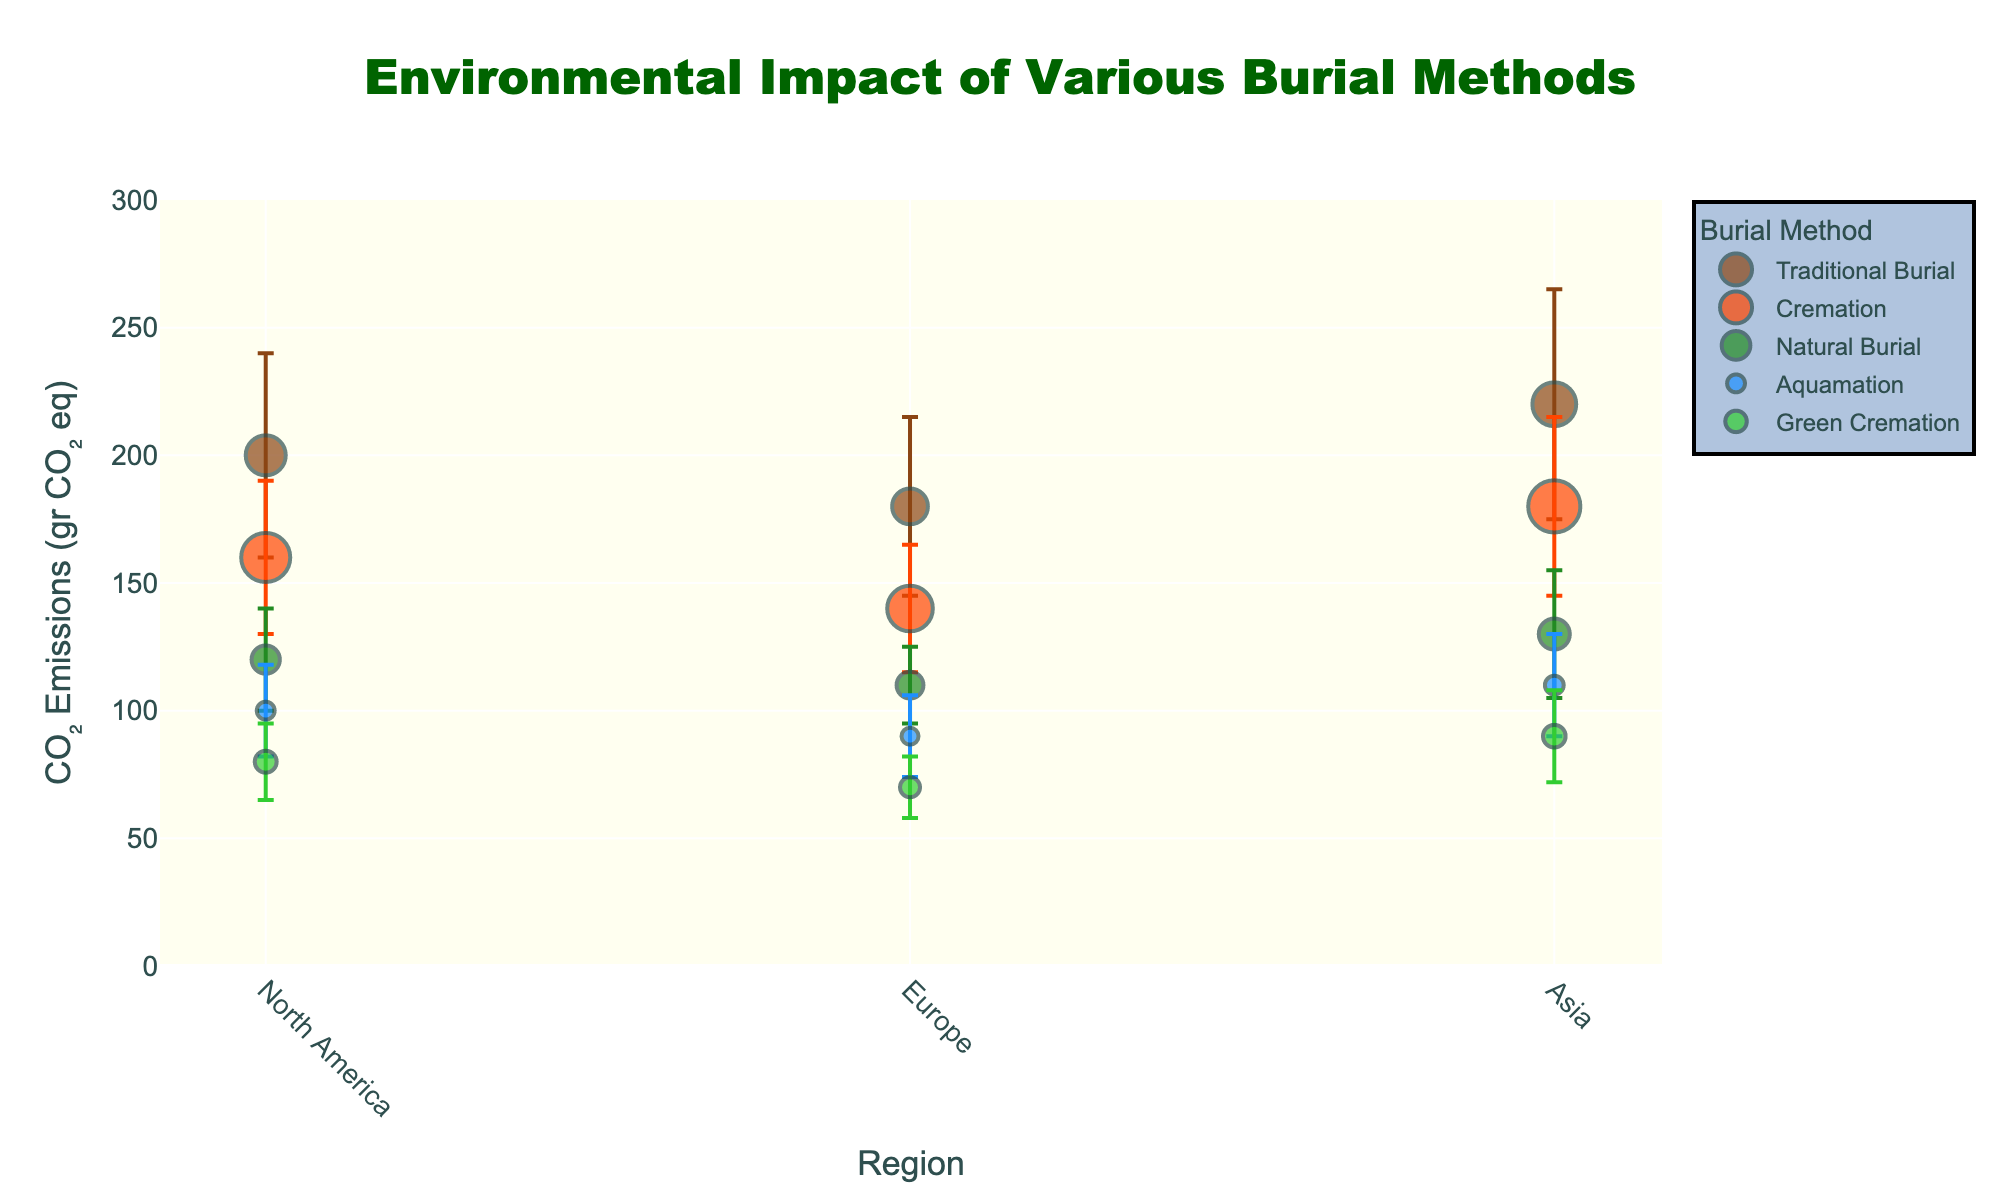What is the title of the figure? The title is usually found at the top of the figure, often in larger or bold text. In this case, it reads "Environmental Impact of Various Burial Methods".
Answer: Environmental Impact of Various Burial Methods Which burial method has the smallest CO₂ emissions in Europe? Looking at the region 'Europe' on the x-axis and comparing the y-axis values, Green Cremation has the smallest CO₂ emissions.
Answer: Green Cremation How do the CO₂ emissions for Traditional Burial in Asia compare to those in Europe? In Asia, Traditional Burial has CO₂ emissions around 220 gr CO₂ eq, while in Europe it is around 180 gr CO₂ eq. Thus, Asia has higher emissions.
Answer: Higher in Asia Which region has the most significant spread in CO₂ emissions for Natural Burial? The spread can be determined by looking at the error bars. For Natural Burial, Asia has the largest error bar (25 gr CO₂ eq), indicating the most significant spread.
Answer: Asia What is the range of CO₂ emissions for Cremation in North America, considering the error bars? The mean value for Cremation in North America is 160 gr CO₂ eq with an error of 30 gr CO₂ eq. So the range is from 130 to 190 gr CO₂ eq.
Answer: 130 to 190 gr CO₂ eq Compare the implementation numbers of Natural Burial in Europe and Aquamation in North America. Which is more, and by how much? Natural Burial in Europe has 4500 implementations, while Aquamation in North America has 2000. The difference is 4500 - 2000 = 2500.
Answer: Natural Burial by 2500 Which burial method has the least variability in CO₂ emissions across all regions? To find the least variability, look at the smallest error bars across different methods. Green Cremation generally has smaller error bars across all regions.
Answer: Green Cremation What is the average CO₂ emissions for Aquamation across all regions? Sum the mean CO₂ emissions for Aquamation (100, 90, 110) and divide by the number of regions (3): (100 + 90 + 110) / 3 = 100 gr CO₂ eq.
Answer: 100 gr CO₂ eq How does the size of the marker for Traditional Burial in North America compare to that for Green Cremation in Asia? The size of the markers is proportional to the square root of the number of implementations. Traditional Burial in North America has 10000 implementations, and Green Cremation in Asia has 3200. The size is larger for Traditional Burial in North America.
Answer: Larger for Traditional Burial in North America What is the overall trend in CO₂ emissions as we move from Traditional Burial to Green Cremation across the regions? Generally, as we move from Traditional Burial to Cremation, to Natural Burial, to Aquamation, and finally to Green Cremation, the CO₂ emissions decrease across North America, Europe, and Asia.
Answer: Decreasing trend 